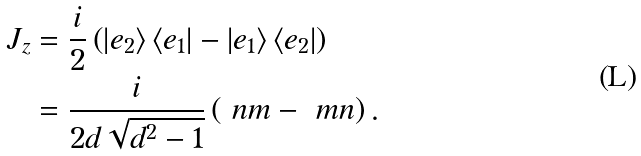Convert formula to latex. <formula><loc_0><loc_0><loc_500><loc_500>J _ { z } & = \frac { i } { 2 } \left ( \left | e _ { 2 } \right \rangle \left \langle e _ { 1 } \right | - \left | e _ { 1 } \right \rangle \left \langle e _ { 2 } \right | \right ) \\ & = \frac { i } { 2 d \sqrt { d ^ { 2 } - 1 } } \left ( \ n m - \ m n \right ) .</formula> 